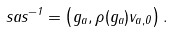<formula> <loc_0><loc_0><loc_500><loc_500>s a s ^ { - 1 } = \left ( g _ { a } , \rho ( g _ { a } ) v _ { a , 0 } \right ) .</formula> 